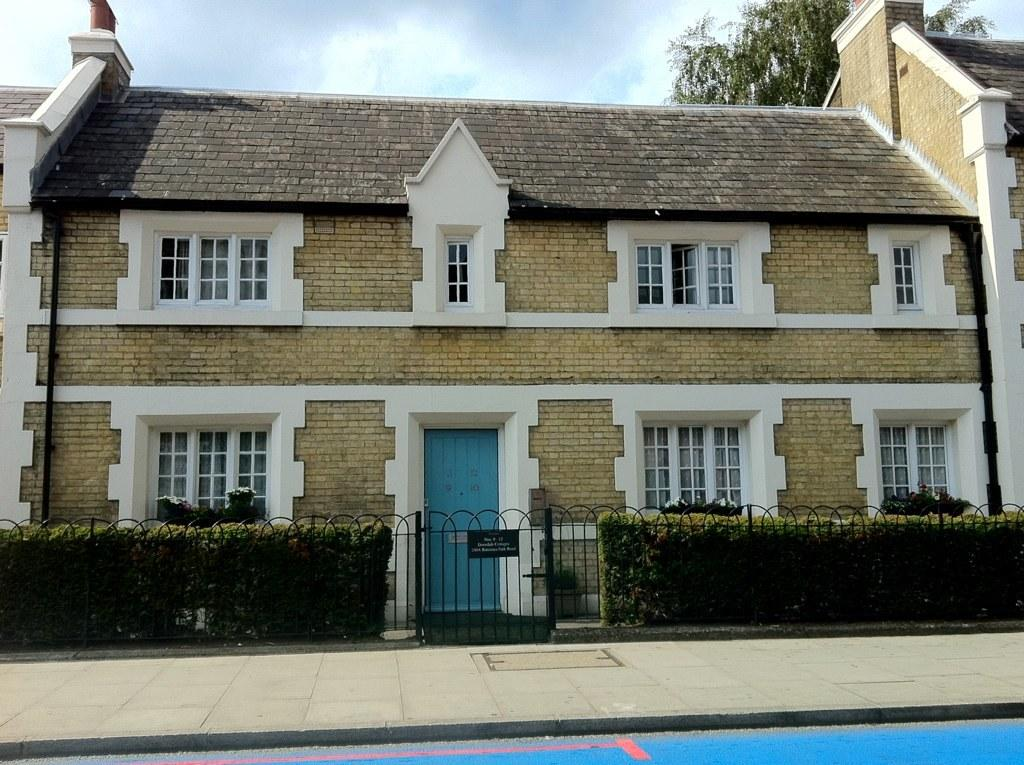What type of structure is visible in the image? There is a house in the image. What features can be seen on the house? The house has windows and a door. What is the entrance to the property in the image? There is a gate in the image. What is used to enclose the property in the image? There is a fence in the image. What type of vegetation is present in the image? There are plants in the image. What is the surface in front of the house made of? There is a pavement in front of the house. What can be seen in the background of the image? There is a tree and the sky visible in the background of the image. Where is the sugar stored in the image? There is no sugar present in the image. What type of zipper can be seen on the fence in the image? There is no zipper present on the fence in the image. 